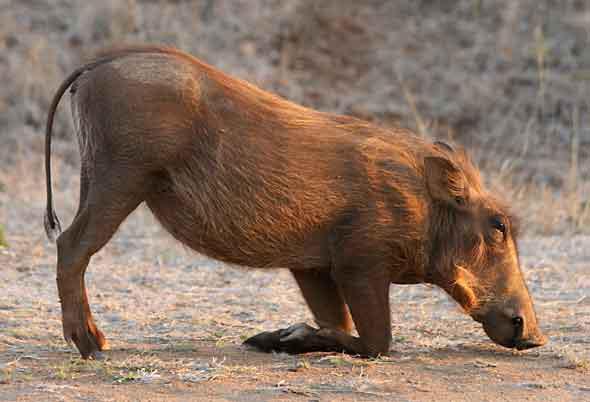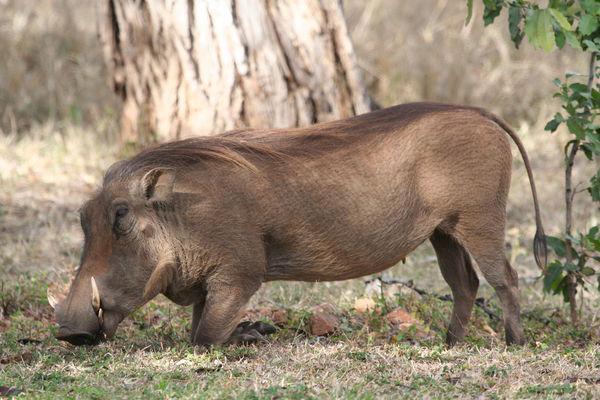The first image is the image on the left, the second image is the image on the right. Given the left and right images, does the statement "At least one animal in one of the images in near a watery area." hold true? Answer yes or no. No. The first image is the image on the left, the second image is the image on the right. Given the left and right images, does the statement "Each image shows exactly one warthog, which is standing with its front knees on the ground." hold true? Answer yes or no. Yes. 